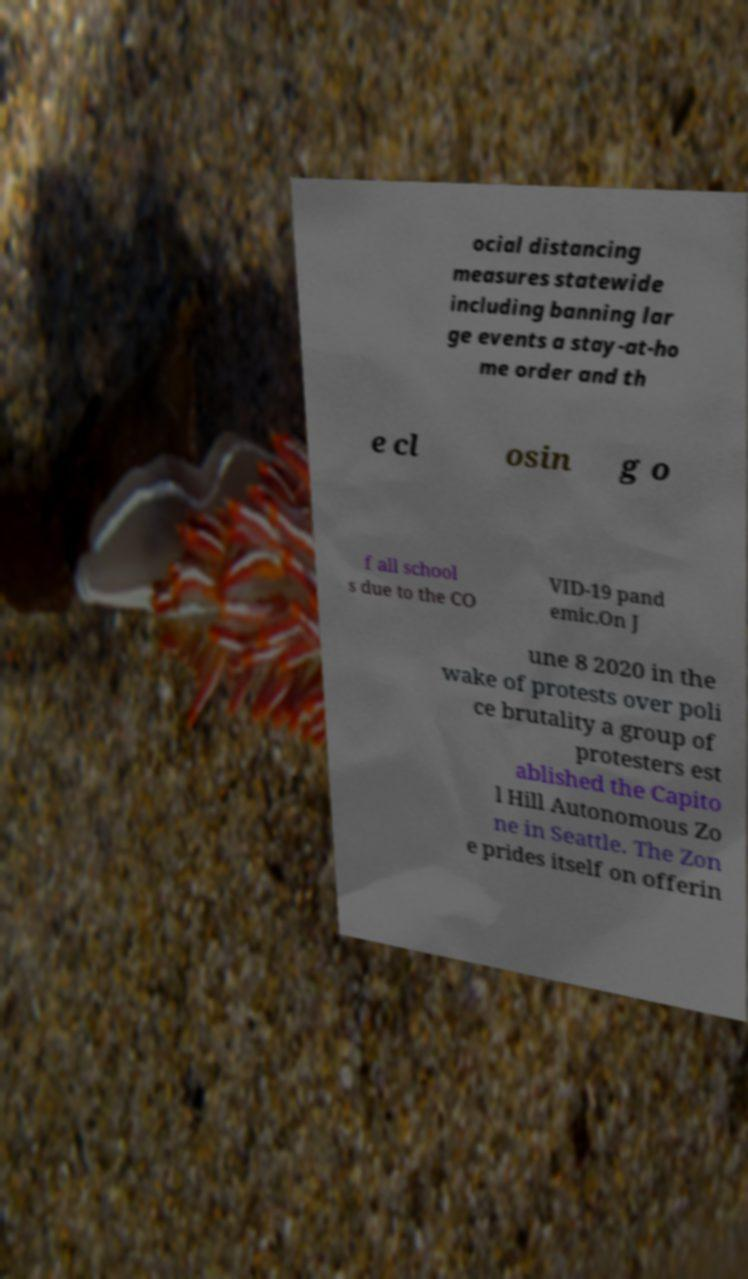There's text embedded in this image that I need extracted. Can you transcribe it verbatim? ocial distancing measures statewide including banning lar ge events a stay-at-ho me order and th e cl osin g o f all school s due to the CO VID-19 pand emic.On J une 8 2020 in the wake of protests over poli ce brutality a group of protesters est ablished the Capito l Hill Autonomous Zo ne in Seattle. The Zon e prides itself on offerin 